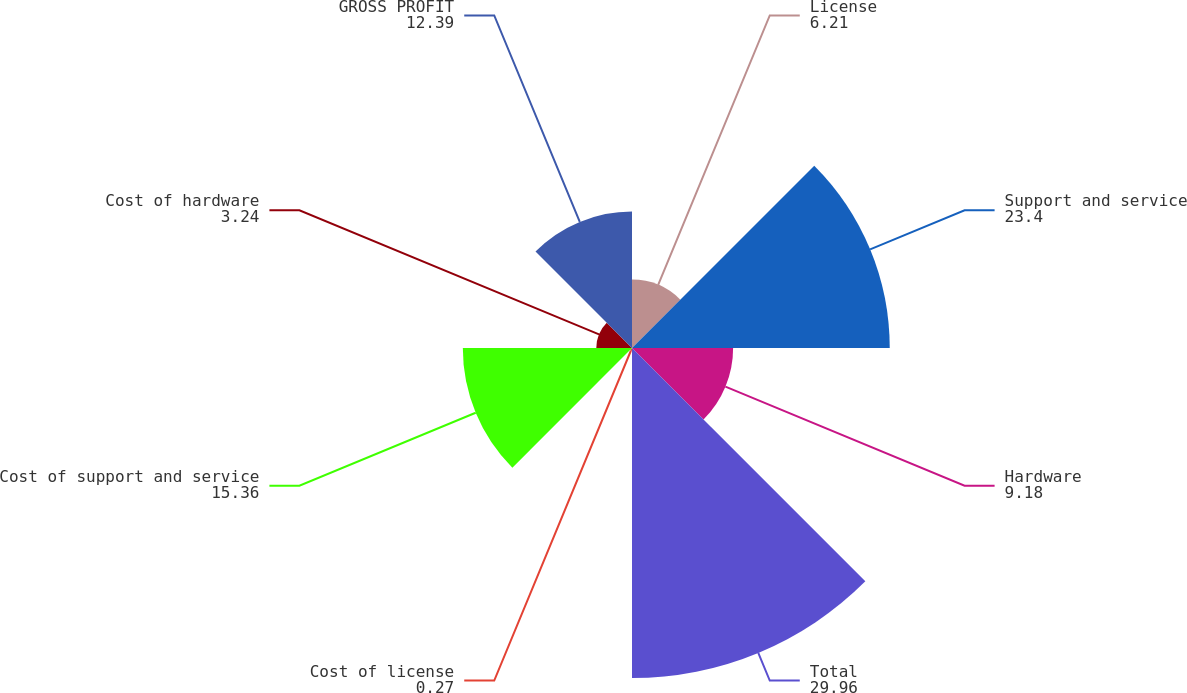Convert chart to OTSL. <chart><loc_0><loc_0><loc_500><loc_500><pie_chart><fcel>License<fcel>Support and service<fcel>Hardware<fcel>Total<fcel>Cost of license<fcel>Cost of support and service<fcel>Cost of hardware<fcel>GROSS PROFIT<nl><fcel>6.21%<fcel>23.4%<fcel>9.18%<fcel>29.96%<fcel>0.27%<fcel>15.36%<fcel>3.24%<fcel>12.39%<nl></chart> 